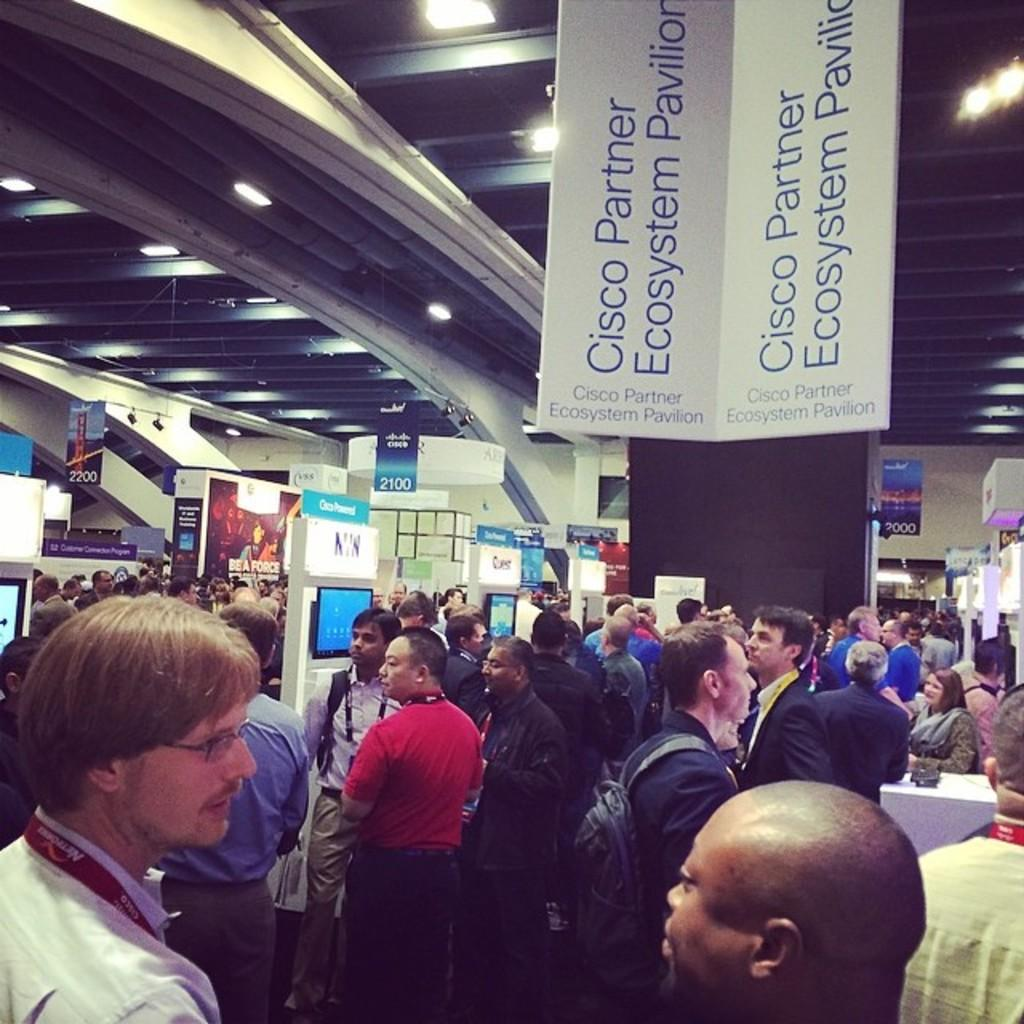What is happening in the image? There are people standing in the image. What can be seen on the wall in the image? There are TV screens on the wall. What is hanging from the top in the image? There are banners hanging from the top. What is on the roof in the image? There are lights on the roof. What type of grain is being harvested in the image? There is no grain or harvesting activity present in the image. What mode of transportation is being used for the journey in the image? There is no journey or transportation depicted in the image. 